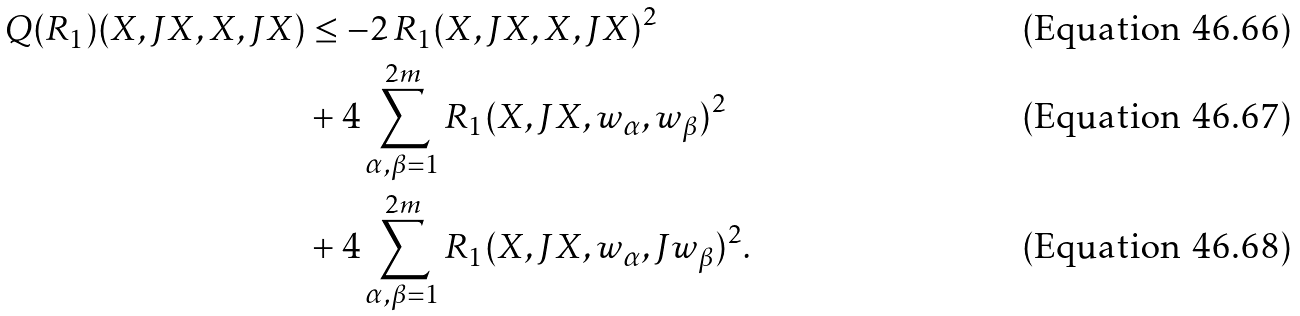<formula> <loc_0><loc_0><loc_500><loc_500>Q ( R _ { 1 } ) ( X , J X , X , J X ) & \leq - 2 \, R _ { 1 } ( X , J X , X , J X ) ^ { 2 } \\ & + 4 \sum _ { \alpha , \beta = 1 } ^ { 2 m } R _ { 1 } ( X , J X , w _ { \alpha } , w _ { \beta } ) ^ { 2 } \\ & + 4 \sum _ { \alpha , \beta = 1 } ^ { 2 m } R _ { 1 } ( X , J X , w _ { \alpha } , J w _ { \beta } ) ^ { 2 } .</formula> 